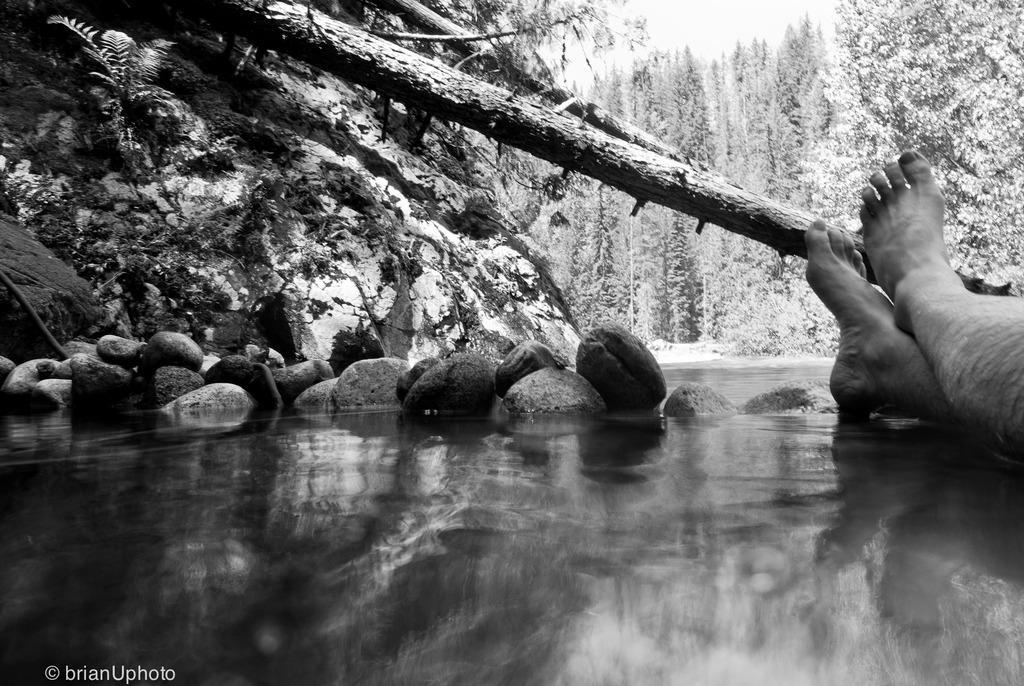Describe this image in one or two sentences. In the picture we can see the surface with some stones and a part if the tree and beside it, we can see a person's legs and in the background we can see the trees. 